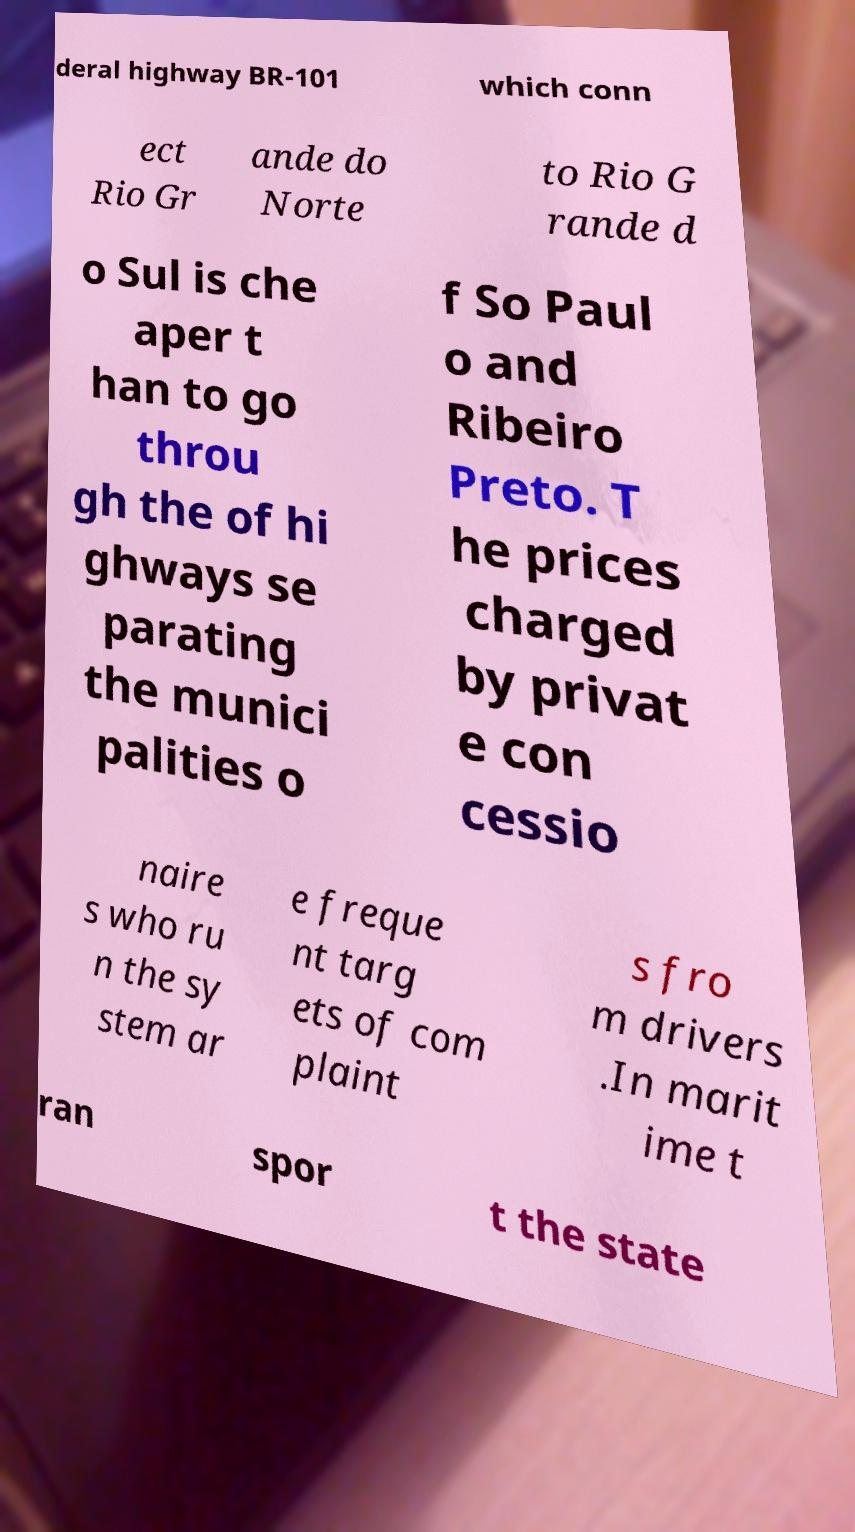I need the written content from this picture converted into text. Can you do that? deral highway BR-101 which conn ect Rio Gr ande do Norte to Rio G rande d o Sul is che aper t han to go throu gh the of hi ghways se parating the munici palities o f So Paul o and Ribeiro Preto. T he prices charged by privat e con cessio naire s who ru n the sy stem ar e freque nt targ ets of com plaint s fro m drivers .In marit ime t ran spor t the state 